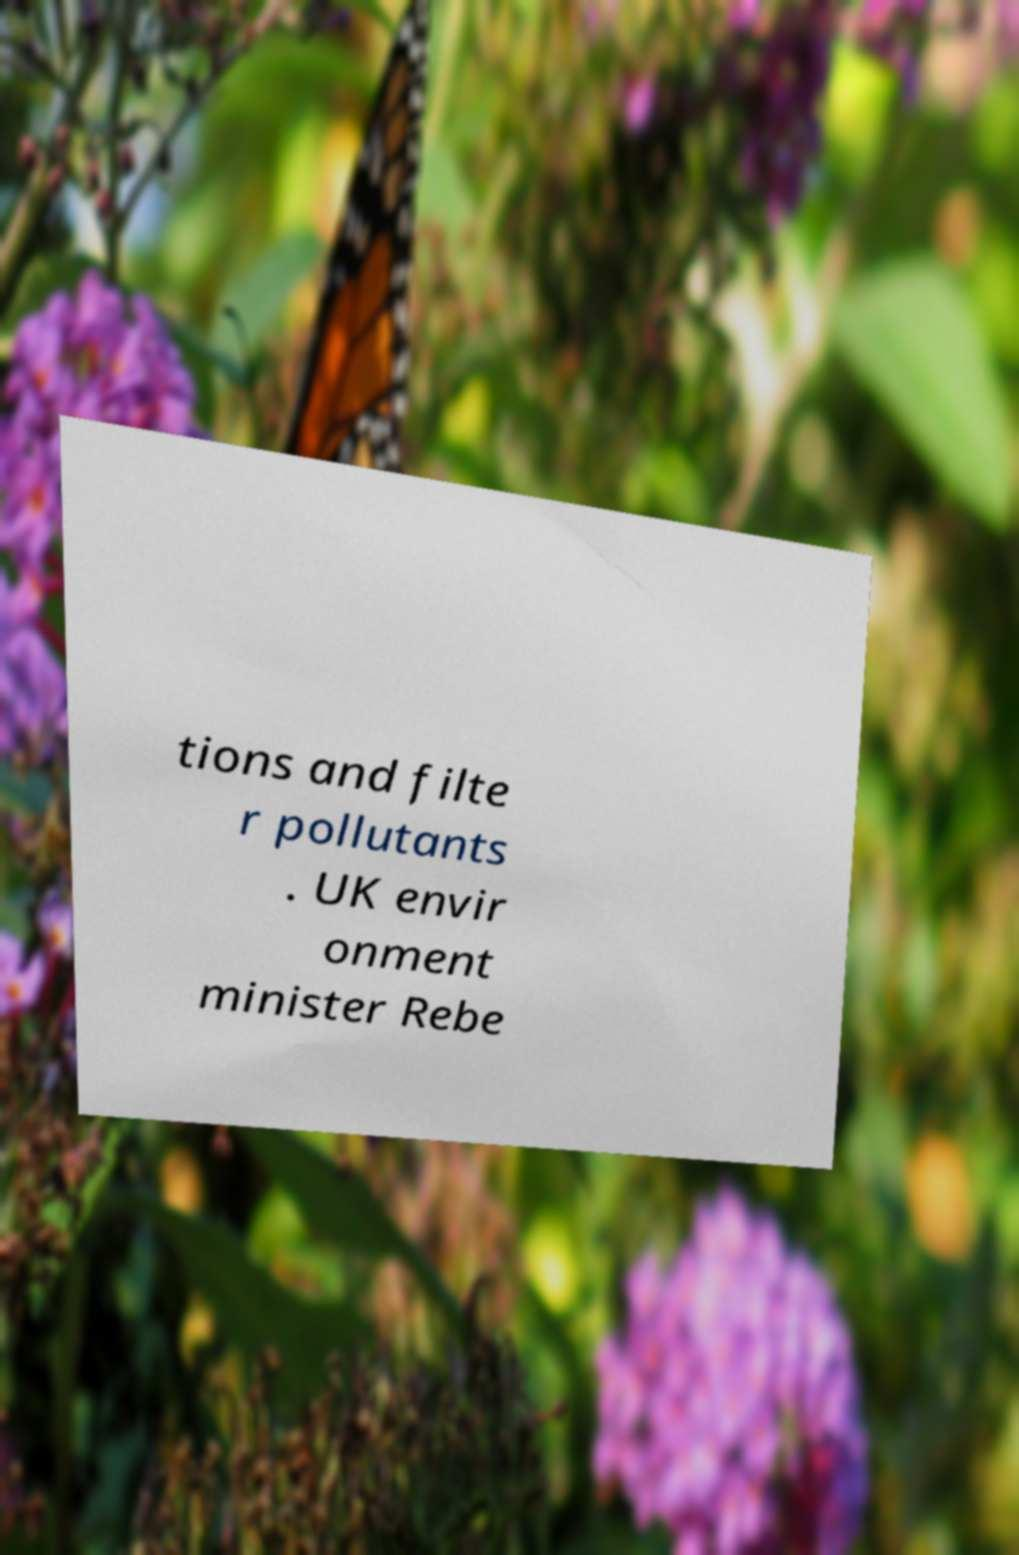What messages or text are displayed in this image? I need them in a readable, typed format. tions and filte r pollutants . UK envir onment minister Rebe 